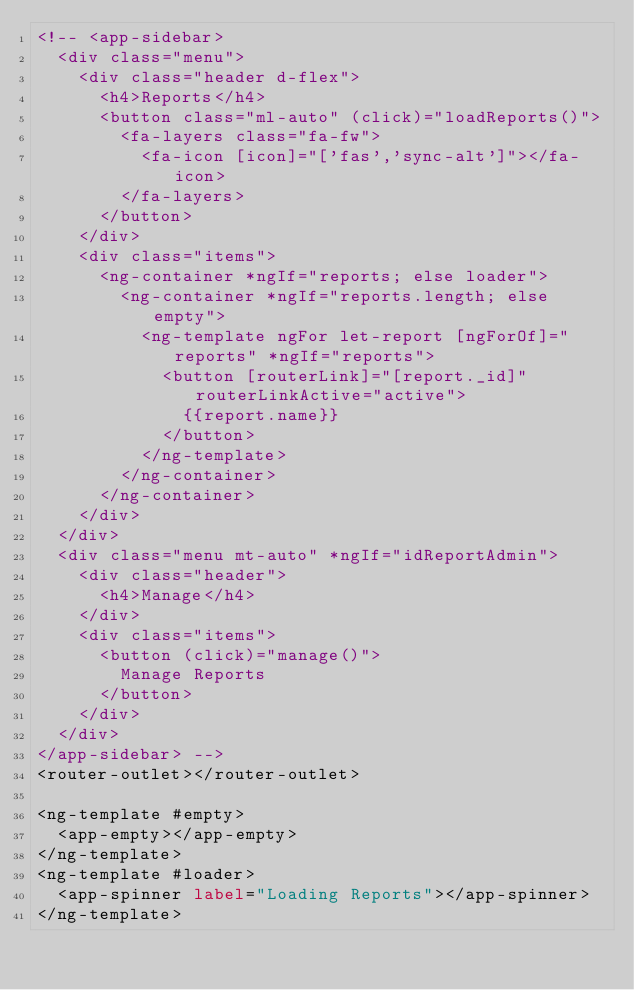<code> <loc_0><loc_0><loc_500><loc_500><_HTML_><!-- <app-sidebar>
  <div class="menu">
    <div class="header d-flex">
      <h4>Reports</h4>
      <button class="ml-auto" (click)="loadReports()">
        <fa-layers class="fa-fw">
          <fa-icon [icon]="['fas','sync-alt']"></fa-icon>
        </fa-layers>
      </button>
    </div>
    <div class="items">
      <ng-container *ngIf="reports; else loader">
        <ng-container *ngIf="reports.length; else empty">
          <ng-template ngFor let-report [ngForOf]="reports" *ngIf="reports">
            <button [routerLink]="[report._id]" routerLinkActive="active">
              {{report.name}}
            </button>
          </ng-template>
        </ng-container>
      </ng-container>
    </div>
  </div>
  <div class="menu mt-auto" *ngIf="idReportAdmin">
    <div class="header">
      <h4>Manage</h4>
    </div>
    <div class="items">
      <button (click)="manage()">
        Manage Reports
      </button>
    </div>
  </div>
</app-sidebar> -->
<router-outlet></router-outlet>

<ng-template #empty>
  <app-empty></app-empty>
</ng-template>
<ng-template #loader>
  <app-spinner label="Loading Reports"></app-spinner>
</ng-template>
</code> 